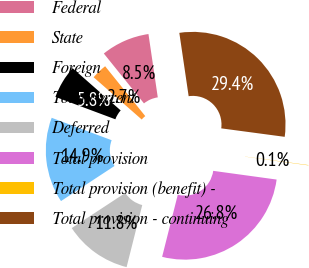Convert chart. <chart><loc_0><loc_0><loc_500><loc_500><pie_chart><fcel>Federal<fcel>State<fcel>Foreign<fcel>Total current<fcel>Deferred<fcel>Total provision<fcel>Total provision (benefit) -<fcel>Total provision - continuing<nl><fcel>8.46%<fcel>2.74%<fcel>5.78%<fcel>14.93%<fcel>11.83%<fcel>26.76%<fcel>0.06%<fcel>29.44%<nl></chart> 